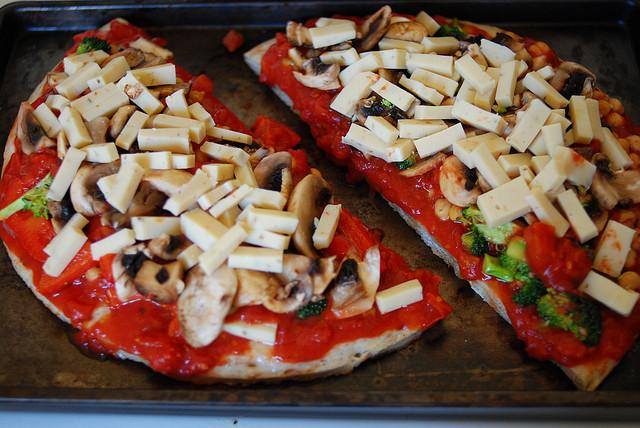What are the white things?
Give a very brief answer. Cheese. What is the protein on this plate?
Give a very brief answer. Cheese. Is this pizza cooked?
Concise answer only. No. What kind of mushroom is that?
Answer briefly. Bella. How is the pizza cut?
Quick response, please. Half. What is the pizza on?
Short answer required. Wooden board. Is the pizza done?
Short answer required. No. Is the cheese melted?
Keep it brief. No. Are there mushrooms on the pizza?
Write a very short answer. Yes. 